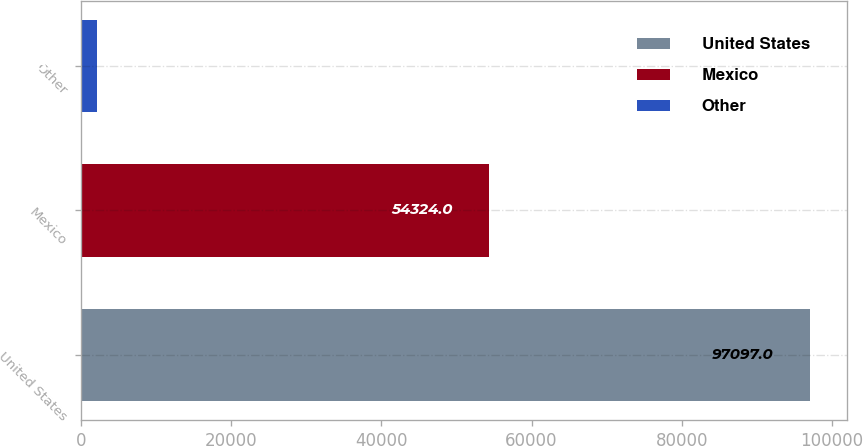Convert chart to OTSL. <chart><loc_0><loc_0><loc_500><loc_500><bar_chart><fcel>United States<fcel>Mexico<fcel>Other<nl><fcel>97097<fcel>54324<fcel>2095<nl></chart> 